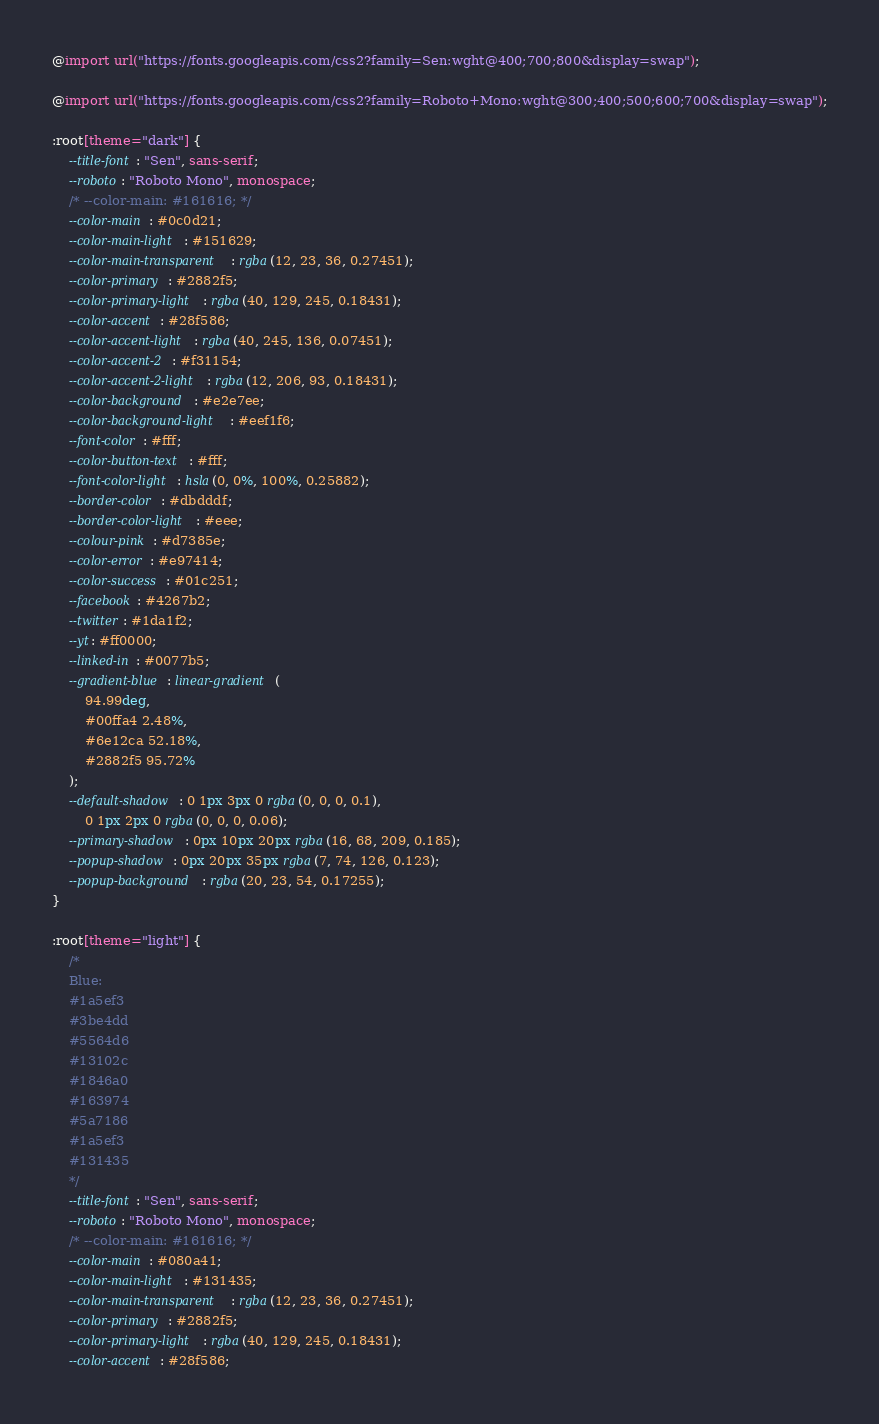<code> <loc_0><loc_0><loc_500><loc_500><_CSS_>@import url("https://fonts.googleapis.com/css2?family=Sen:wght@400;700;800&display=swap");

@import url("https://fonts.googleapis.com/css2?family=Roboto+Mono:wght@300;400;500;600;700&display=swap");

:root[theme="dark"] {
	--title-font: "Sen", sans-serif;
	--roboto: "Roboto Mono", monospace;
	/* --color-main: #161616; */
	--color-main: #0c0d21;
	--color-main-light: #151629;
	--color-main-transparent: rgba(12, 23, 36, 0.27451);
	--color-primary: #2882f5;
	--color-primary-light: rgba(40, 129, 245, 0.18431);
	--color-accent: #28f586;
	--color-accent-light: rgba(40, 245, 136, 0.07451);
	--color-accent-2: #f31154;
	--color-accent-2-light: rgba(12, 206, 93, 0.18431);
	--color-background: #e2e7ee;
	--color-background-light: #eef1f6;
	--font-color: #fff;
	--color-button-text: #fff;
	--font-color-light: hsla(0, 0%, 100%, 0.25882);
	--border-color: #dbdddf;
	--border-color-light: #eee;
	--colour-pink: #d7385e;
	--color-error: #e97414;
	--color-success: #01c251;
	--facebook: #4267b2;
	--twitter: #1da1f2;
	--yt: #ff0000;
	--linked-in: #0077b5;
	--gradient-blue: linear-gradient(
		94.99deg,
		#00ffa4 2.48%,
		#6e12ca 52.18%,
		#2882f5 95.72%
	);
	--default-shadow: 0 1px 3px 0 rgba(0, 0, 0, 0.1),
		0 1px 2px 0 rgba(0, 0, 0, 0.06);
	--primary-shadow: 0px 10px 20px rgba(16, 68, 209, 0.185);
	--popup-shadow: 0px 20px 35px rgba(7, 74, 126, 0.123);
	--popup-background: rgba(20, 23, 54, 0.17255);
}

:root[theme="light"] {
	/* 
	Blue:
	#1a5ef3
	#3be4dd
	#5564d6
	#13102c
	#1846a0
	#163974
	#5a7186
	#1a5ef3
	#131435
	*/
	--title-font: "Sen", sans-serif;
	--roboto: "Roboto Mono", monospace;
	/* --color-main: #161616; */
	--color-main: #080a41;
	--color-main-light: #131435;
	--color-main-transparent: rgba(12, 23, 36, 0.27451);
	--color-primary: #2882f5;
	--color-primary-light: rgba(40, 129, 245, 0.18431);
	--color-accent: #28f586;</code> 